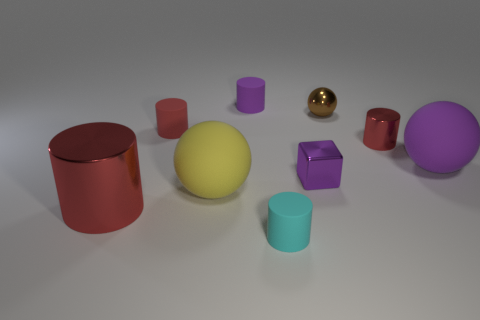What number of objects are tiny objects or small matte things on the right side of the purple cylinder? On the right side of the purple cylinder, there are three small objects: one is a tiny red cup, another is a small purple cube, and the third is a small golden sphere. These objects appear to be smaller than other items in the image, highlighting their relative scale and placement. 